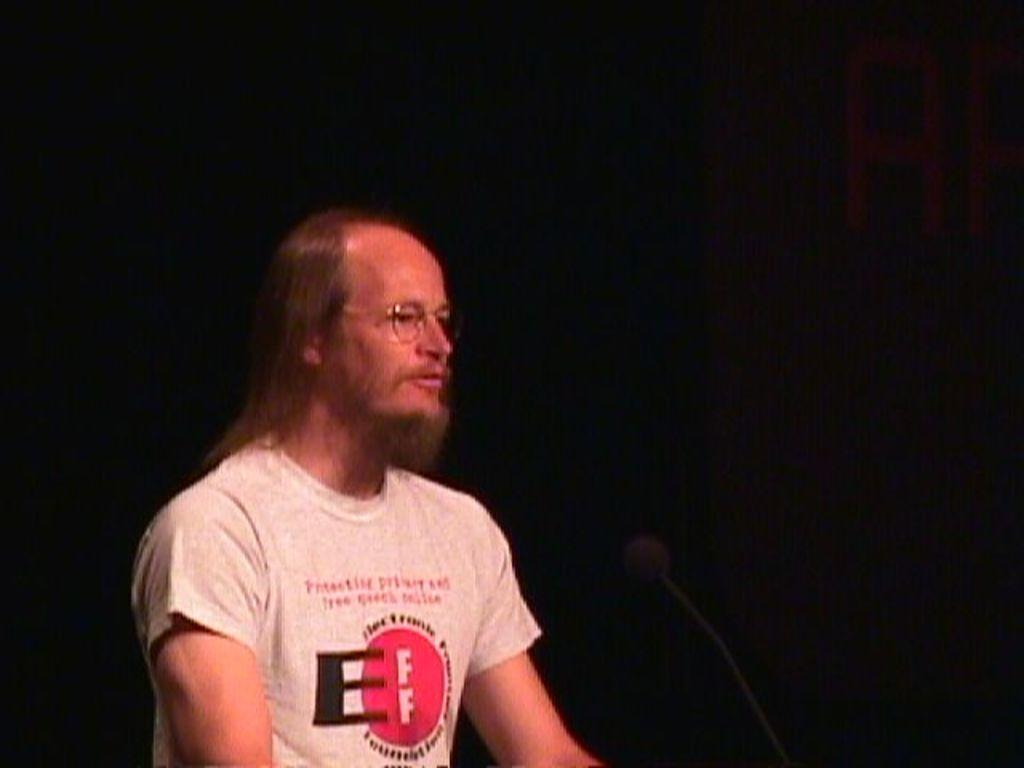How would you summarize this image in a sentence or two? In this image I can see a person wearing white, red and black colored t shirt and I can see a microphone in front of him. I can see the black colored background. 